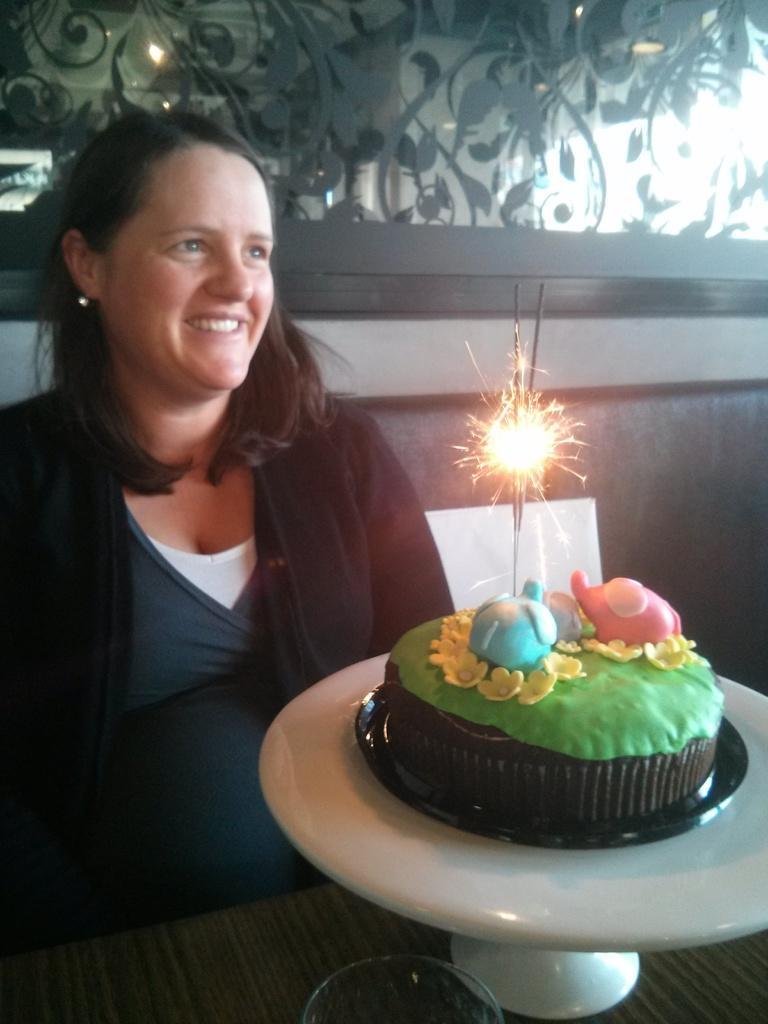Describe this image in one or two sentences. In this image, we can see a person sitting. We can see a cake with a sparkle on a white object is placed on the surface. We can see a glass. We can see the sofa. We can see the wall and some glass. 